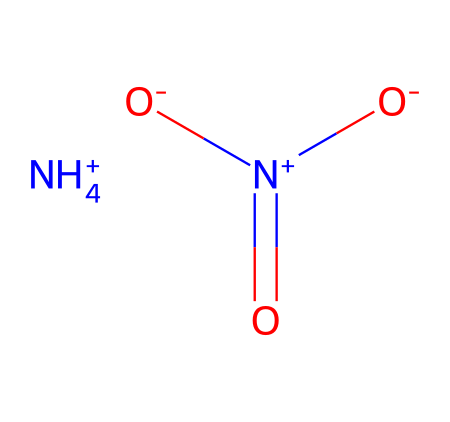What is the formula for ammonium nitrate? The structural representation indicates the presence of ammonium (NH4+) and nitrate (NO3-), and when combined, the formula is derived from these components.
Answer: ammonium nitrate How many nitrogen atoms are present in the molecule? Analyzing the structure reveals one nitrogen in the ammonium ion and one nitrogen in the nitrate ion, so there are a total of two nitrogen atoms.
Answer: two What type of bonds are present in ammonium nitrate? The structure shows ionic bonds between the ammonium ion and the nitrate ion, and covalent bonds within the ions themselves.
Answer: ionic and covalent Which ion has a positive charge? The ammonium ion (NH4+) is the only ion in the structure with a positive charge as indicated by the plus sign.
Answer: ammonium How does the presence of the nitrate ion contribute to the properties of ammonium nitrate? The nitrate ion imparts soluble properties and is essential for the fertilizer's role in providing nitrogen to plants, which is vital for growth.
Answer: nitrogen source What are the common uses for ammonium nitrate? Because of its properties as a nutrient-rich fertilizer, ammonium nitrate is frequently used in agriculture to enhance plant growth and is also used in explosives.
Answer: fertilizer and explosives 